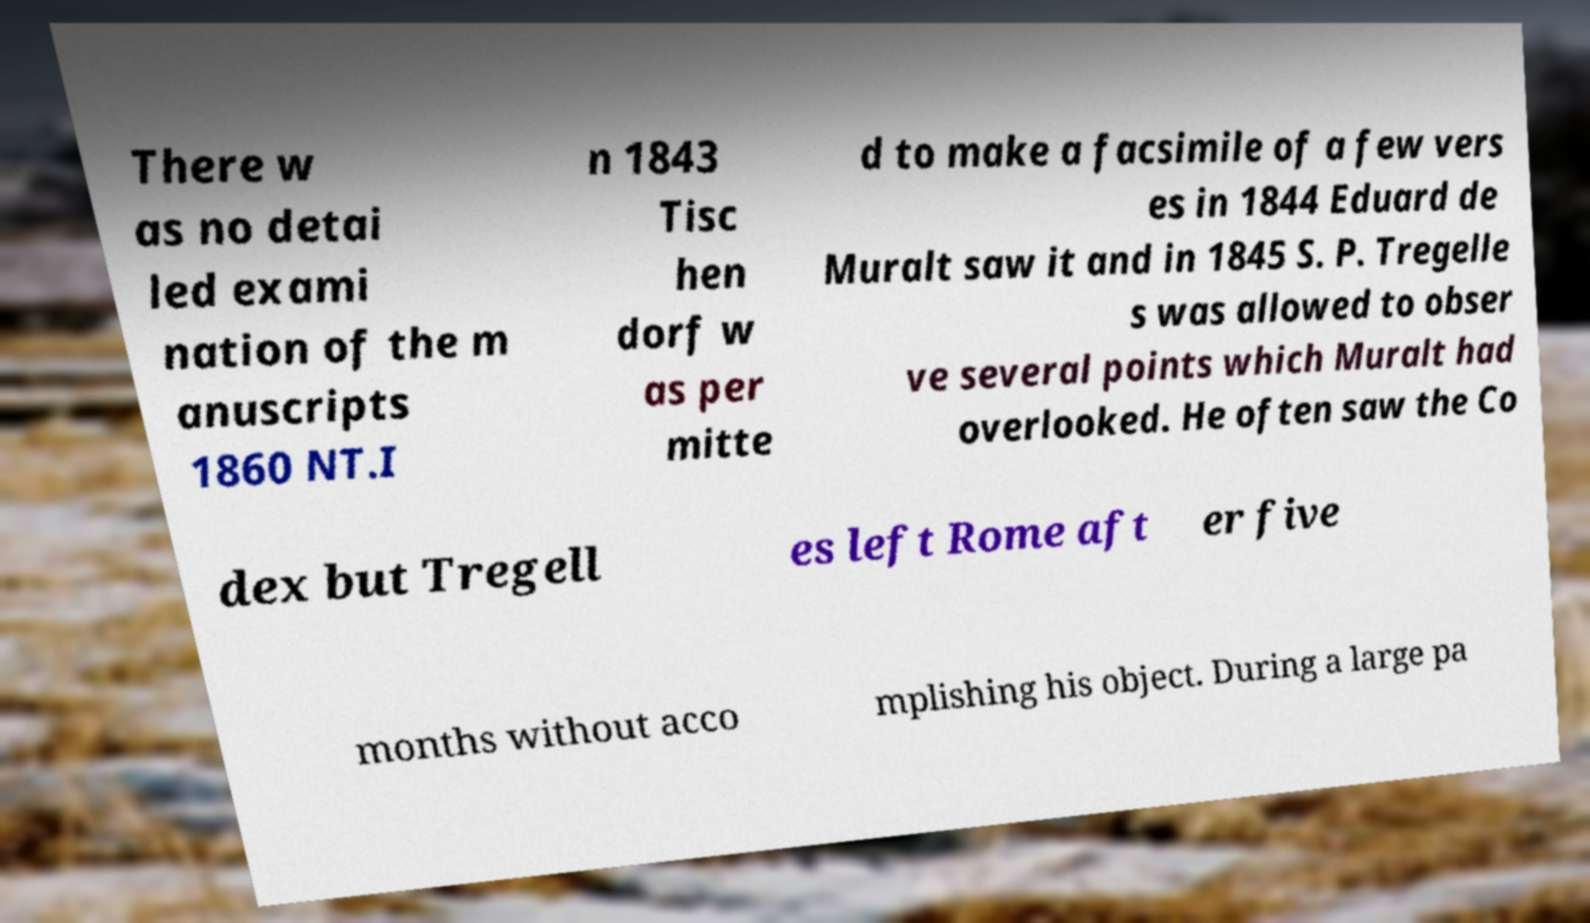What messages or text are displayed in this image? I need them in a readable, typed format. There w as no detai led exami nation of the m anuscripts 1860 NT.I n 1843 Tisc hen dorf w as per mitte d to make a facsimile of a few vers es in 1844 Eduard de Muralt saw it and in 1845 S. P. Tregelle s was allowed to obser ve several points which Muralt had overlooked. He often saw the Co dex but Tregell es left Rome aft er five months without acco mplishing his object. During a large pa 